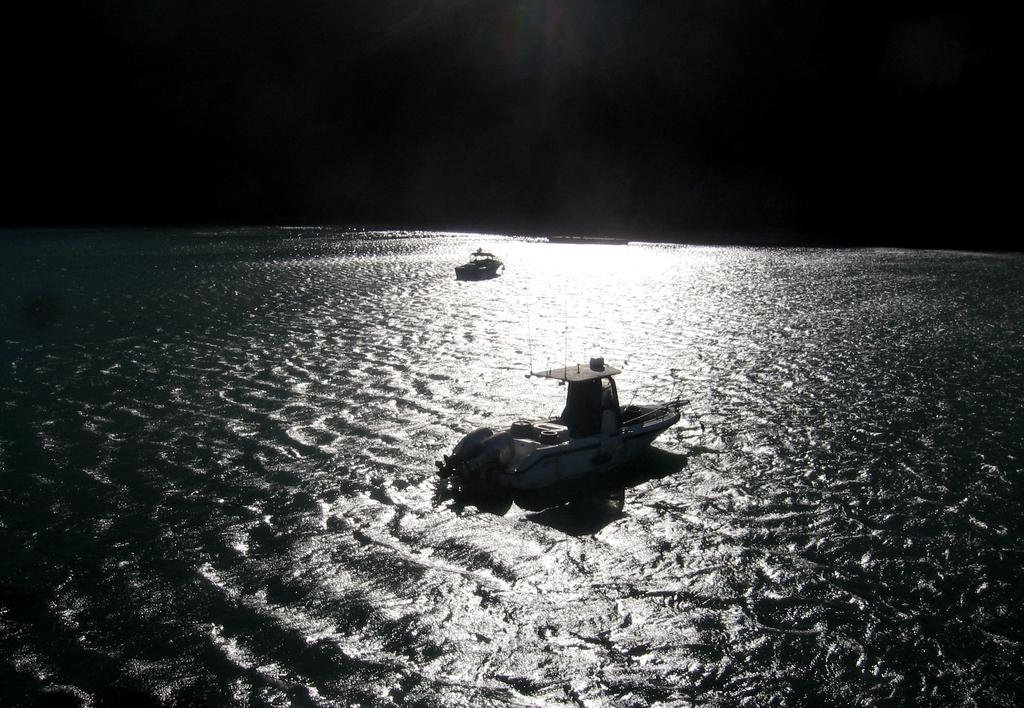What type of vehicles can be seen on the water in the image? There are boats on the surface of water in the image. What is the primary element in which the boats are situated? The boats are situated on the surface of water. What is the color of the sky or the top part of the image? The top of the image appears to be dark. How does the boat slip on the water in the image? The image does not show the boat slipping on the water; it only shows the boats on the surface of water. Are the people on the boats sleeping in the image? There is no indication of people or their activities on the boats in the image. 